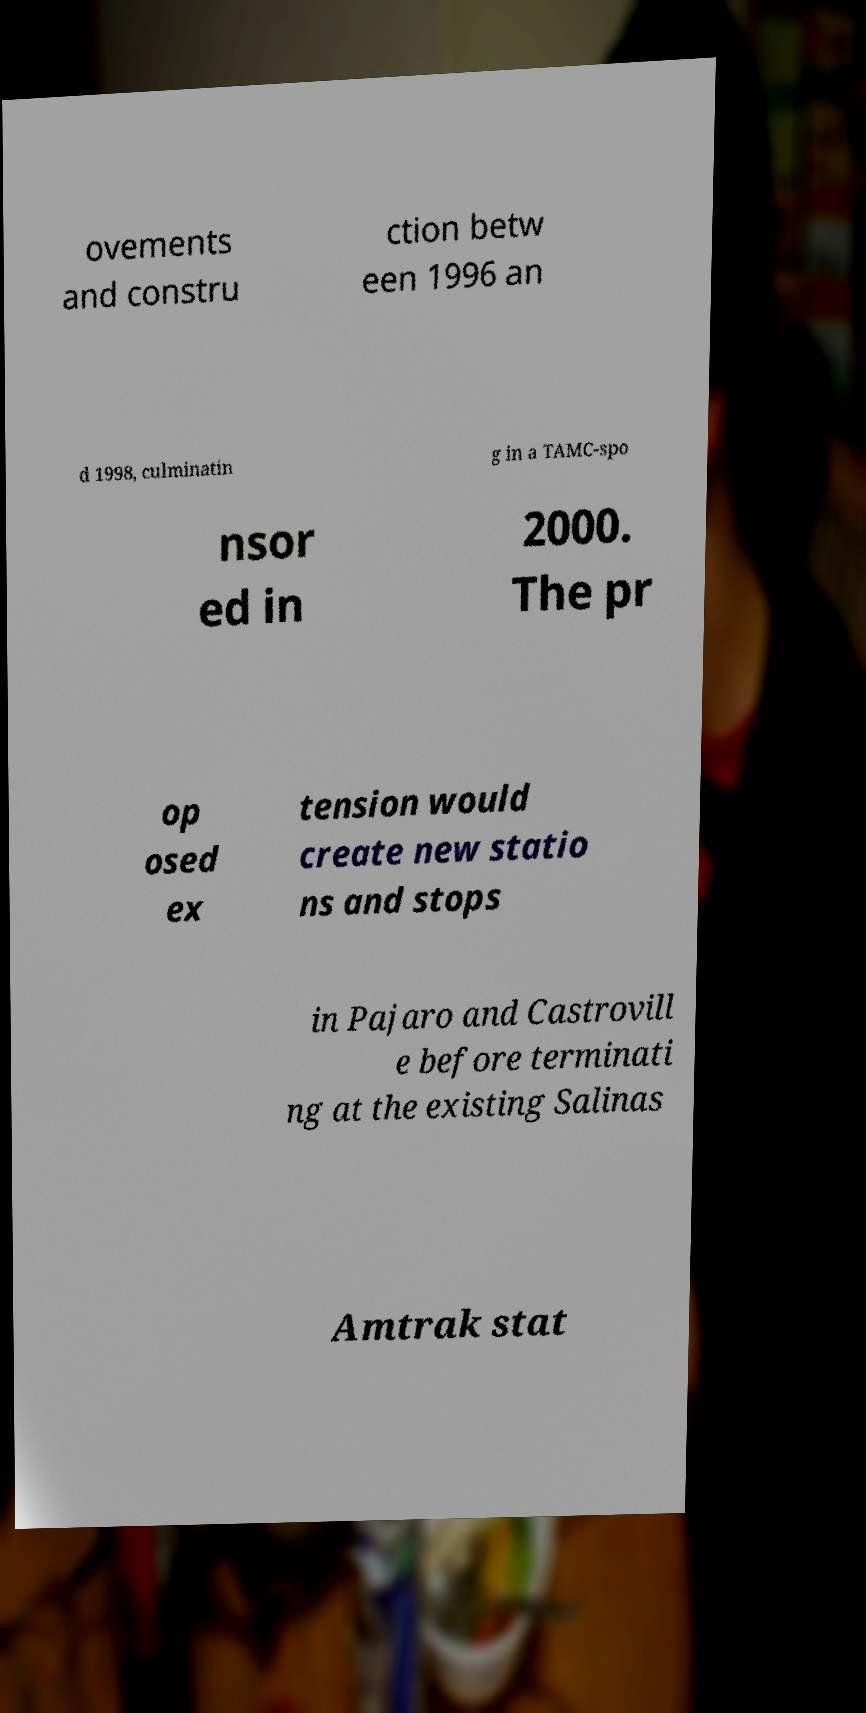Can you read and provide the text displayed in the image?This photo seems to have some interesting text. Can you extract and type it out for me? ovements and constru ction betw een 1996 an d 1998, culminatin g in a TAMC-spo nsor ed in 2000. The pr op osed ex tension would create new statio ns and stops in Pajaro and Castrovill e before terminati ng at the existing Salinas Amtrak stat 